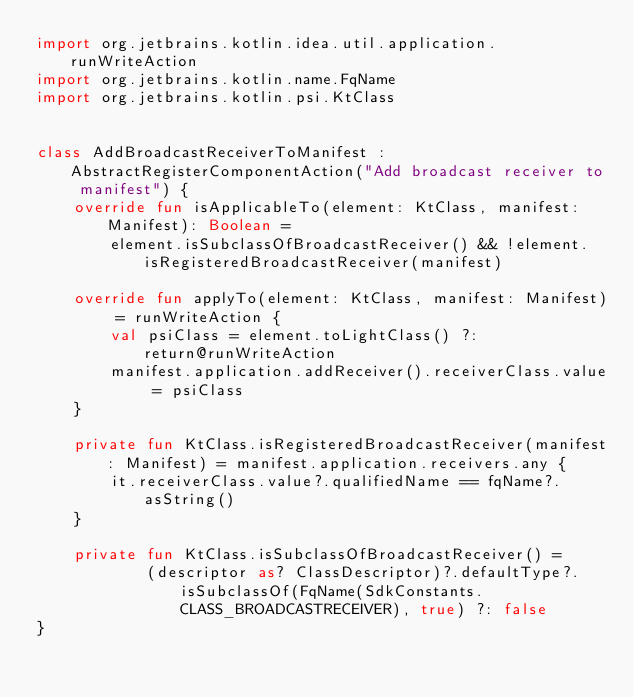<code> <loc_0><loc_0><loc_500><loc_500><_Kotlin_>import org.jetbrains.kotlin.idea.util.application.runWriteAction
import org.jetbrains.kotlin.name.FqName
import org.jetbrains.kotlin.psi.KtClass


class AddBroadcastReceiverToManifest : AbstractRegisterComponentAction("Add broadcast receiver to manifest") {
    override fun isApplicableTo(element: KtClass, manifest: Manifest): Boolean =
        element.isSubclassOfBroadcastReceiver() && !element.isRegisteredBroadcastReceiver(manifest)

    override fun applyTo(element: KtClass, manifest: Manifest) = runWriteAction {
        val psiClass = element.toLightClass() ?: return@runWriteAction
        manifest.application.addReceiver().receiverClass.value = psiClass
    }

    private fun KtClass.isRegisteredBroadcastReceiver(manifest: Manifest) = manifest.application.receivers.any {
        it.receiverClass.value?.qualifiedName == fqName?.asString()
    }

    private fun KtClass.isSubclassOfBroadcastReceiver() =
            (descriptor as? ClassDescriptor)?.defaultType?.isSubclassOf(FqName(SdkConstants.CLASS_BROADCASTRECEIVER), true) ?: false
}</code> 